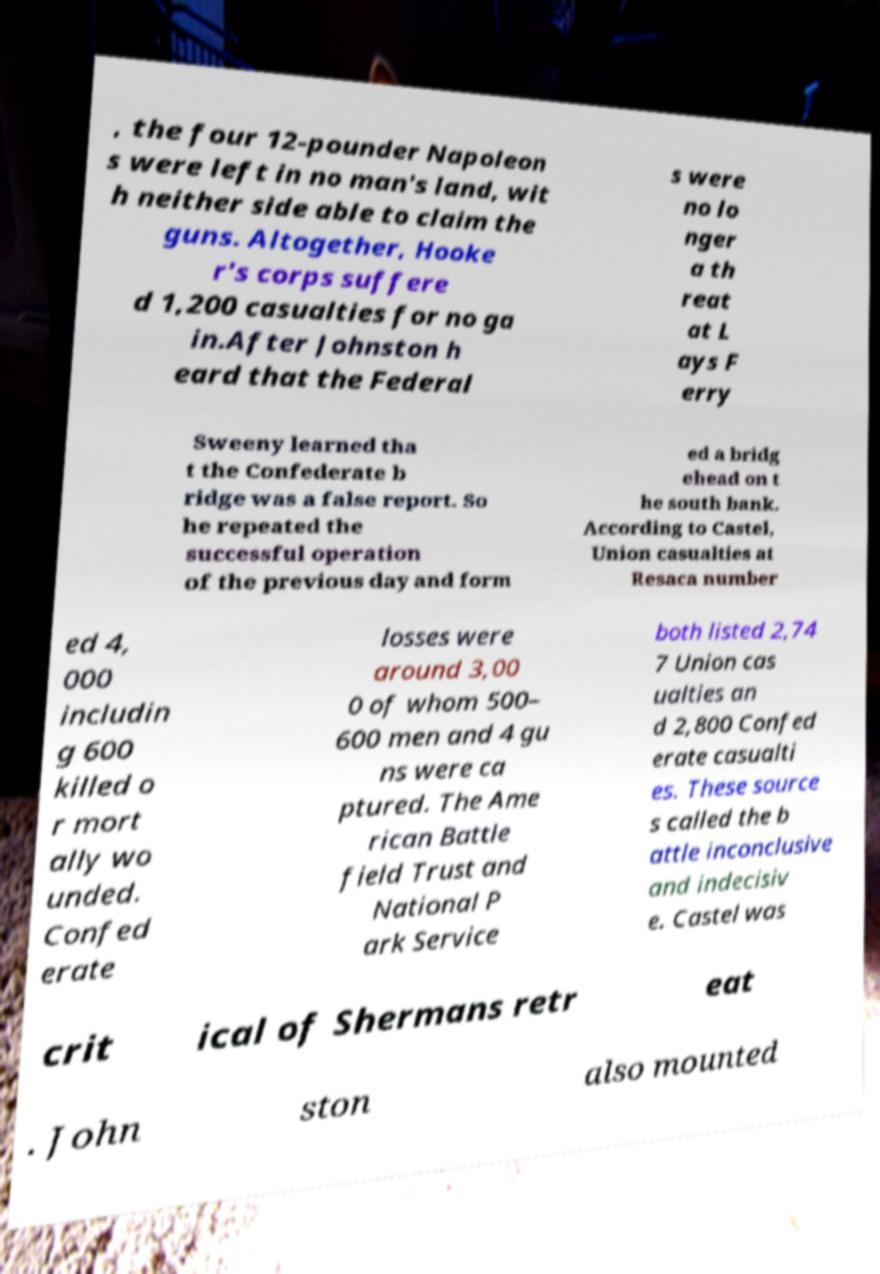What messages or text are displayed in this image? I need them in a readable, typed format. , the four 12-pounder Napoleon s were left in no man's land, wit h neither side able to claim the guns. Altogether, Hooke r's corps suffere d 1,200 casualties for no ga in.After Johnston h eard that the Federal s were no lo nger a th reat at L ays F erry Sweeny learned tha t the Confederate b ridge was a false report. So he repeated the successful operation of the previous day and form ed a bridg ehead on t he south bank. According to Castel, Union casualties at Resaca number ed 4, 000 includin g 600 killed o r mort ally wo unded. Confed erate losses were around 3,00 0 of whom 500– 600 men and 4 gu ns were ca ptured. The Ame rican Battle field Trust and National P ark Service both listed 2,74 7 Union cas ualties an d 2,800 Confed erate casualti es. These source s called the b attle inconclusive and indecisiv e. Castel was crit ical of Shermans retr eat . John ston also mounted 